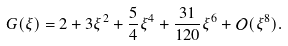Convert formula to latex. <formula><loc_0><loc_0><loc_500><loc_500>G ( \xi ) = 2 + 3 \xi ^ { 2 } + \frac { 5 } { 4 } \xi ^ { 4 } + \frac { 3 1 } { 1 2 0 } \xi ^ { 6 } + \mathcal { O } ( \xi ^ { 8 } ) .</formula> 